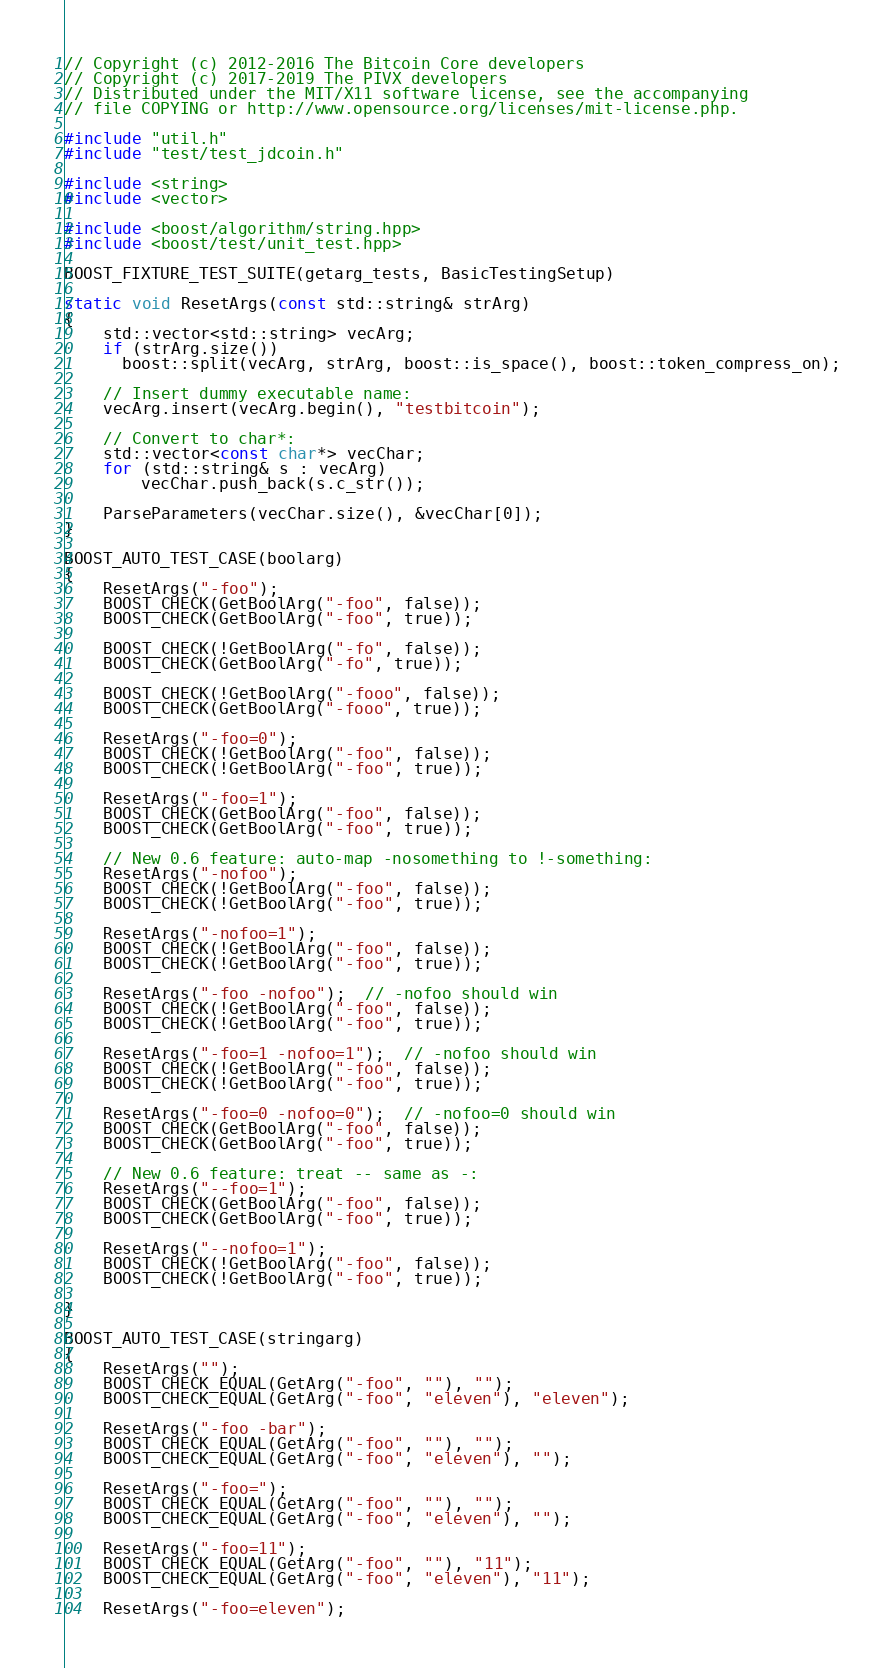Convert code to text. <code><loc_0><loc_0><loc_500><loc_500><_C++_>// Copyright (c) 2012-2016 The Bitcoin Core developers
// Copyright (c) 2017-2019 The PIVX developers
// Distributed under the MIT/X11 software license, see the accompanying
// file COPYING or http://www.opensource.org/licenses/mit-license.php.

#include "util.h"
#include "test/test_jdcoin.h"

#include <string>
#include <vector>

#include <boost/algorithm/string.hpp>
#include <boost/test/unit_test.hpp>

BOOST_FIXTURE_TEST_SUITE(getarg_tests, BasicTestingSetup)

static void ResetArgs(const std::string& strArg)
{
    std::vector<std::string> vecArg;
    if (strArg.size())
      boost::split(vecArg, strArg, boost::is_space(), boost::token_compress_on);

    // Insert dummy executable name:
    vecArg.insert(vecArg.begin(), "testbitcoin");

    // Convert to char*:
    std::vector<const char*> vecChar;
    for (std::string& s : vecArg)
        vecChar.push_back(s.c_str());

    ParseParameters(vecChar.size(), &vecChar[0]);
}

BOOST_AUTO_TEST_CASE(boolarg)
{
    ResetArgs("-foo");
    BOOST_CHECK(GetBoolArg("-foo", false));
    BOOST_CHECK(GetBoolArg("-foo", true));

    BOOST_CHECK(!GetBoolArg("-fo", false));
    BOOST_CHECK(GetBoolArg("-fo", true));

    BOOST_CHECK(!GetBoolArg("-fooo", false));
    BOOST_CHECK(GetBoolArg("-fooo", true));

    ResetArgs("-foo=0");
    BOOST_CHECK(!GetBoolArg("-foo", false));
    BOOST_CHECK(!GetBoolArg("-foo", true));

    ResetArgs("-foo=1");
    BOOST_CHECK(GetBoolArg("-foo", false));
    BOOST_CHECK(GetBoolArg("-foo", true));

    // New 0.6 feature: auto-map -nosomething to !-something:
    ResetArgs("-nofoo");
    BOOST_CHECK(!GetBoolArg("-foo", false));
    BOOST_CHECK(!GetBoolArg("-foo", true));

    ResetArgs("-nofoo=1");
    BOOST_CHECK(!GetBoolArg("-foo", false));
    BOOST_CHECK(!GetBoolArg("-foo", true));

    ResetArgs("-foo -nofoo");  // -nofoo should win
    BOOST_CHECK(!GetBoolArg("-foo", false));
    BOOST_CHECK(!GetBoolArg("-foo", true));

    ResetArgs("-foo=1 -nofoo=1");  // -nofoo should win
    BOOST_CHECK(!GetBoolArg("-foo", false));
    BOOST_CHECK(!GetBoolArg("-foo", true));

    ResetArgs("-foo=0 -nofoo=0");  // -nofoo=0 should win
    BOOST_CHECK(GetBoolArg("-foo", false));
    BOOST_CHECK(GetBoolArg("-foo", true));

    // New 0.6 feature: treat -- same as -:
    ResetArgs("--foo=1");
    BOOST_CHECK(GetBoolArg("-foo", false));
    BOOST_CHECK(GetBoolArg("-foo", true));

    ResetArgs("--nofoo=1");
    BOOST_CHECK(!GetBoolArg("-foo", false));
    BOOST_CHECK(!GetBoolArg("-foo", true));

}

BOOST_AUTO_TEST_CASE(stringarg)
{
    ResetArgs("");
    BOOST_CHECK_EQUAL(GetArg("-foo", ""), "");
    BOOST_CHECK_EQUAL(GetArg("-foo", "eleven"), "eleven");

    ResetArgs("-foo -bar");
    BOOST_CHECK_EQUAL(GetArg("-foo", ""), "");
    BOOST_CHECK_EQUAL(GetArg("-foo", "eleven"), "");

    ResetArgs("-foo=");
    BOOST_CHECK_EQUAL(GetArg("-foo", ""), "");
    BOOST_CHECK_EQUAL(GetArg("-foo", "eleven"), "");

    ResetArgs("-foo=11");
    BOOST_CHECK_EQUAL(GetArg("-foo", ""), "11");
    BOOST_CHECK_EQUAL(GetArg("-foo", "eleven"), "11");

    ResetArgs("-foo=eleven");</code> 